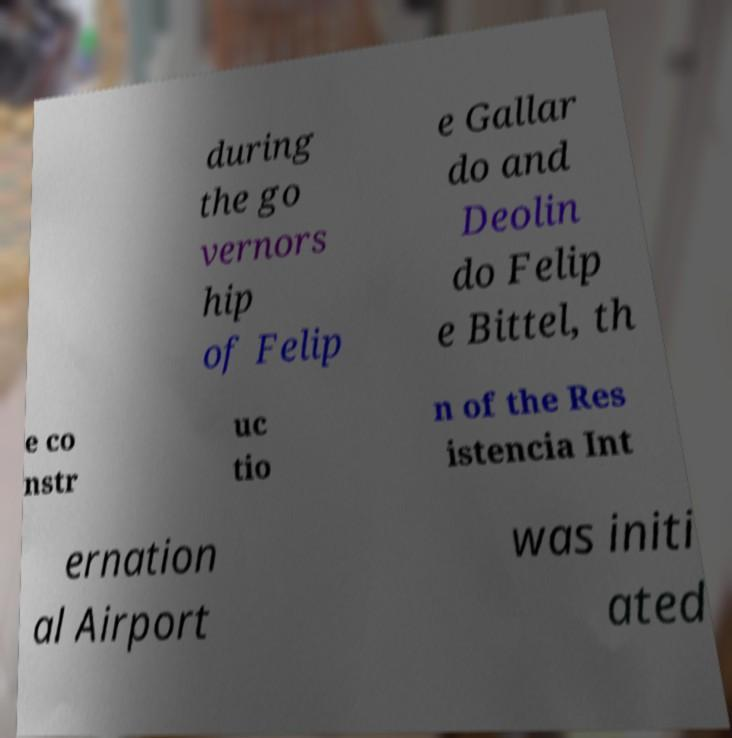Please read and relay the text visible in this image. What does it say? during the go vernors hip of Felip e Gallar do and Deolin do Felip e Bittel, th e co nstr uc tio n of the Res istencia Int ernation al Airport was initi ated 